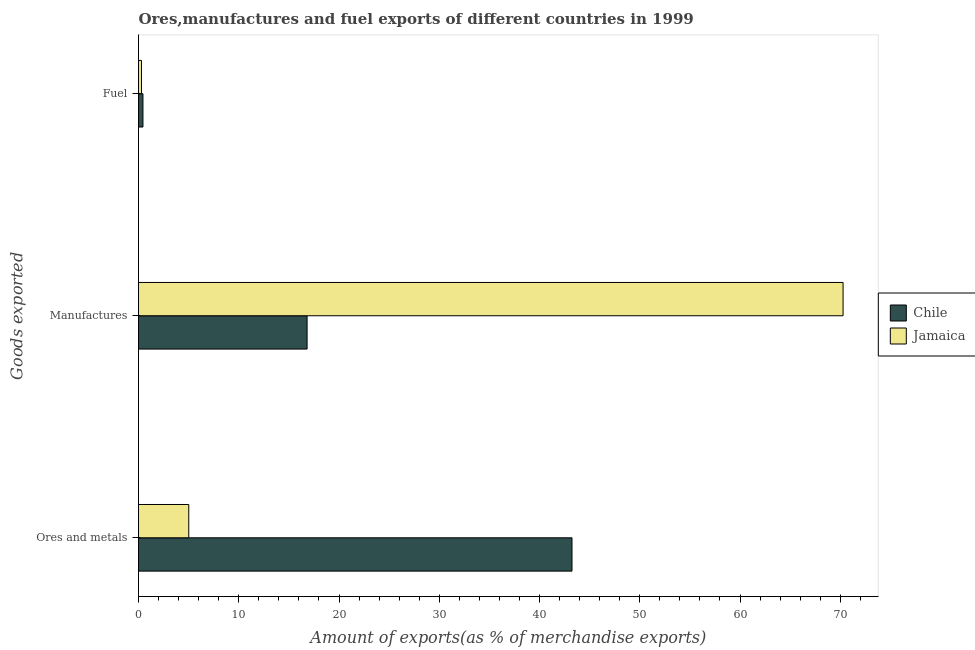How many different coloured bars are there?
Ensure brevity in your answer.  2. How many groups of bars are there?
Keep it short and to the point. 3. Are the number of bars per tick equal to the number of legend labels?
Your answer should be compact. Yes. Are the number of bars on each tick of the Y-axis equal?
Provide a short and direct response. Yes. How many bars are there on the 2nd tick from the top?
Your answer should be very brief. 2. What is the label of the 1st group of bars from the top?
Your answer should be very brief. Fuel. What is the percentage of ores and metals exports in Jamaica?
Offer a very short reply. 5.01. Across all countries, what is the maximum percentage of manufactures exports?
Keep it short and to the point. 70.28. Across all countries, what is the minimum percentage of manufactures exports?
Make the answer very short. 16.82. In which country was the percentage of ores and metals exports minimum?
Offer a very short reply. Jamaica. What is the total percentage of fuel exports in the graph?
Provide a succinct answer. 0.74. What is the difference between the percentage of manufactures exports in Jamaica and that in Chile?
Offer a very short reply. 53.46. What is the difference between the percentage of ores and metals exports in Chile and the percentage of manufactures exports in Jamaica?
Provide a succinct answer. -27.04. What is the average percentage of fuel exports per country?
Provide a short and direct response. 0.37. What is the difference between the percentage of ores and metals exports and percentage of fuel exports in Chile?
Offer a very short reply. 42.8. In how many countries, is the percentage of fuel exports greater than 46 %?
Your answer should be very brief. 0. What is the ratio of the percentage of ores and metals exports in Jamaica to that in Chile?
Your answer should be compact. 0.12. Is the difference between the percentage of ores and metals exports in Jamaica and Chile greater than the difference between the percentage of fuel exports in Jamaica and Chile?
Provide a succinct answer. No. What is the difference between the highest and the second highest percentage of fuel exports?
Provide a succinct answer. 0.15. What is the difference between the highest and the lowest percentage of ores and metals exports?
Your response must be concise. 38.23. What does the 2nd bar from the top in Fuel represents?
Keep it short and to the point. Chile. What does the 2nd bar from the bottom in Manufactures represents?
Your answer should be compact. Jamaica. Is it the case that in every country, the sum of the percentage of ores and metals exports and percentage of manufactures exports is greater than the percentage of fuel exports?
Provide a succinct answer. Yes. What is the difference between two consecutive major ticks on the X-axis?
Your answer should be compact. 10. Does the graph contain grids?
Offer a very short reply. No. How many legend labels are there?
Offer a very short reply. 2. How are the legend labels stacked?
Provide a short and direct response. Vertical. What is the title of the graph?
Make the answer very short. Ores,manufactures and fuel exports of different countries in 1999. Does "Ghana" appear as one of the legend labels in the graph?
Ensure brevity in your answer.  No. What is the label or title of the X-axis?
Give a very brief answer. Amount of exports(as % of merchandise exports). What is the label or title of the Y-axis?
Ensure brevity in your answer.  Goods exported. What is the Amount of exports(as % of merchandise exports) in Chile in Ores and metals?
Your response must be concise. 43.24. What is the Amount of exports(as % of merchandise exports) in Jamaica in Ores and metals?
Offer a very short reply. 5.01. What is the Amount of exports(as % of merchandise exports) of Chile in Manufactures?
Provide a short and direct response. 16.82. What is the Amount of exports(as % of merchandise exports) of Jamaica in Manufactures?
Offer a very short reply. 70.28. What is the Amount of exports(as % of merchandise exports) in Chile in Fuel?
Keep it short and to the point. 0.44. What is the Amount of exports(as % of merchandise exports) in Jamaica in Fuel?
Provide a short and direct response. 0.3. Across all Goods exported, what is the maximum Amount of exports(as % of merchandise exports) of Chile?
Provide a short and direct response. 43.24. Across all Goods exported, what is the maximum Amount of exports(as % of merchandise exports) of Jamaica?
Keep it short and to the point. 70.28. Across all Goods exported, what is the minimum Amount of exports(as % of merchandise exports) of Chile?
Provide a succinct answer. 0.44. Across all Goods exported, what is the minimum Amount of exports(as % of merchandise exports) of Jamaica?
Offer a very short reply. 0.3. What is the total Amount of exports(as % of merchandise exports) in Chile in the graph?
Keep it short and to the point. 60.5. What is the total Amount of exports(as % of merchandise exports) in Jamaica in the graph?
Offer a very short reply. 75.59. What is the difference between the Amount of exports(as % of merchandise exports) in Chile in Ores and metals and that in Manufactures?
Your answer should be very brief. 26.42. What is the difference between the Amount of exports(as % of merchandise exports) of Jamaica in Ores and metals and that in Manufactures?
Your answer should be compact. -65.26. What is the difference between the Amount of exports(as % of merchandise exports) in Chile in Ores and metals and that in Fuel?
Your answer should be compact. 42.8. What is the difference between the Amount of exports(as % of merchandise exports) of Jamaica in Ores and metals and that in Fuel?
Ensure brevity in your answer.  4.72. What is the difference between the Amount of exports(as % of merchandise exports) in Chile in Manufactures and that in Fuel?
Offer a terse response. 16.37. What is the difference between the Amount of exports(as % of merchandise exports) in Jamaica in Manufactures and that in Fuel?
Ensure brevity in your answer.  69.98. What is the difference between the Amount of exports(as % of merchandise exports) in Chile in Ores and metals and the Amount of exports(as % of merchandise exports) in Jamaica in Manufactures?
Your answer should be compact. -27.04. What is the difference between the Amount of exports(as % of merchandise exports) in Chile in Ores and metals and the Amount of exports(as % of merchandise exports) in Jamaica in Fuel?
Offer a very short reply. 42.94. What is the difference between the Amount of exports(as % of merchandise exports) of Chile in Manufactures and the Amount of exports(as % of merchandise exports) of Jamaica in Fuel?
Offer a terse response. 16.52. What is the average Amount of exports(as % of merchandise exports) of Chile per Goods exported?
Give a very brief answer. 20.17. What is the average Amount of exports(as % of merchandise exports) in Jamaica per Goods exported?
Provide a succinct answer. 25.2. What is the difference between the Amount of exports(as % of merchandise exports) in Chile and Amount of exports(as % of merchandise exports) in Jamaica in Ores and metals?
Keep it short and to the point. 38.23. What is the difference between the Amount of exports(as % of merchandise exports) in Chile and Amount of exports(as % of merchandise exports) in Jamaica in Manufactures?
Provide a succinct answer. -53.46. What is the difference between the Amount of exports(as % of merchandise exports) in Chile and Amount of exports(as % of merchandise exports) in Jamaica in Fuel?
Your answer should be compact. 0.15. What is the ratio of the Amount of exports(as % of merchandise exports) of Chile in Ores and metals to that in Manufactures?
Offer a terse response. 2.57. What is the ratio of the Amount of exports(as % of merchandise exports) of Jamaica in Ores and metals to that in Manufactures?
Offer a terse response. 0.07. What is the ratio of the Amount of exports(as % of merchandise exports) of Chile in Ores and metals to that in Fuel?
Offer a very short reply. 97.54. What is the ratio of the Amount of exports(as % of merchandise exports) of Jamaica in Ores and metals to that in Fuel?
Make the answer very short. 16.93. What is the ratio of the Amount of exports(as % of merchandise exports) in Chile in Manufactures to that in Fuel?
Provide a short and direct response. 37.93. What is the ratio of the Amount of exports(as % of merchandise exports) of Jamaica in Manufactures to that in Fuel?
Make the answer very short. 237.43. What is the difference between the highest and the second highest Amount of exports(as % of merchandise exports) of Chile?
Ensure brevity in your answer.  26.42. What is the difference between the highest and the second highest Amount of exports(as % of merchandise exports) of Jamaica?
Your answer should be very brief. 65.26. What is the difference between the highest and the lowest Amount of exports(as % of merchandise exports) in Chile?
Provide a succinct answer. 42.8. What is the difference between the highest and the lowest Amount of exports(as % of merchandise exports) of Jamaica?
Provide a short and direct response. 69.98. 